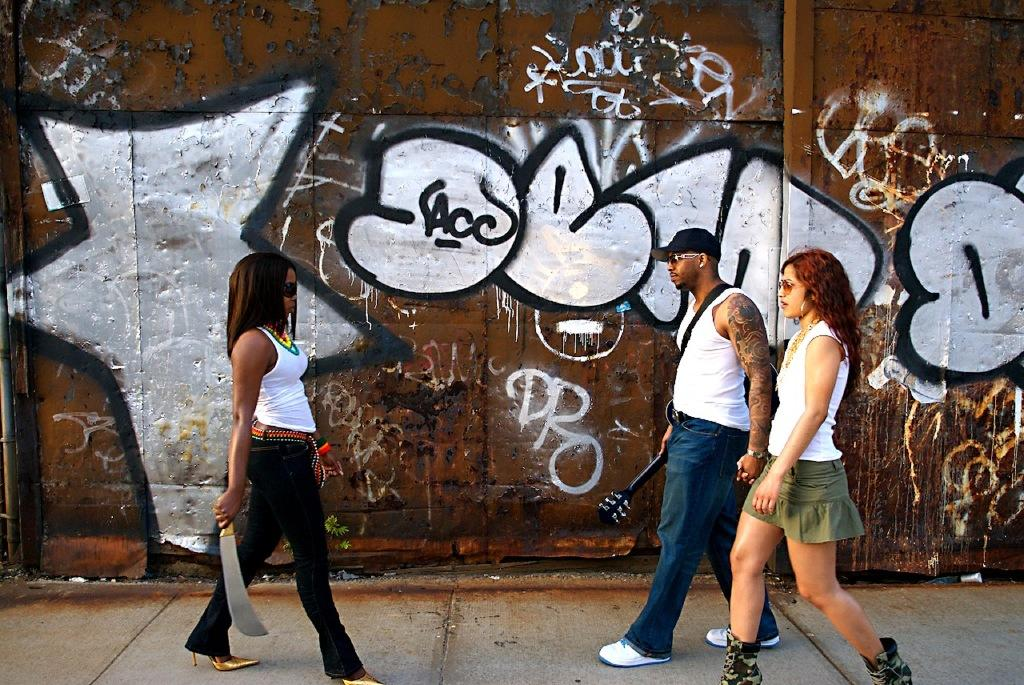What are the people in the image doing? The people in the image are walking on the road. Can you describe the background of the image? There is a painting on a wall in the background of the image. What type of button is being played on the guitar in the image? There is no guitar or button present in the image; it only features people walking on the road and a painting on a wall in the background. 